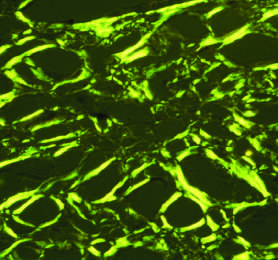does congo red staining show apple-green birefringence under polarized light, a diagnostic feature of amyloid?
Answer the question using a single word or phrase. Yes 